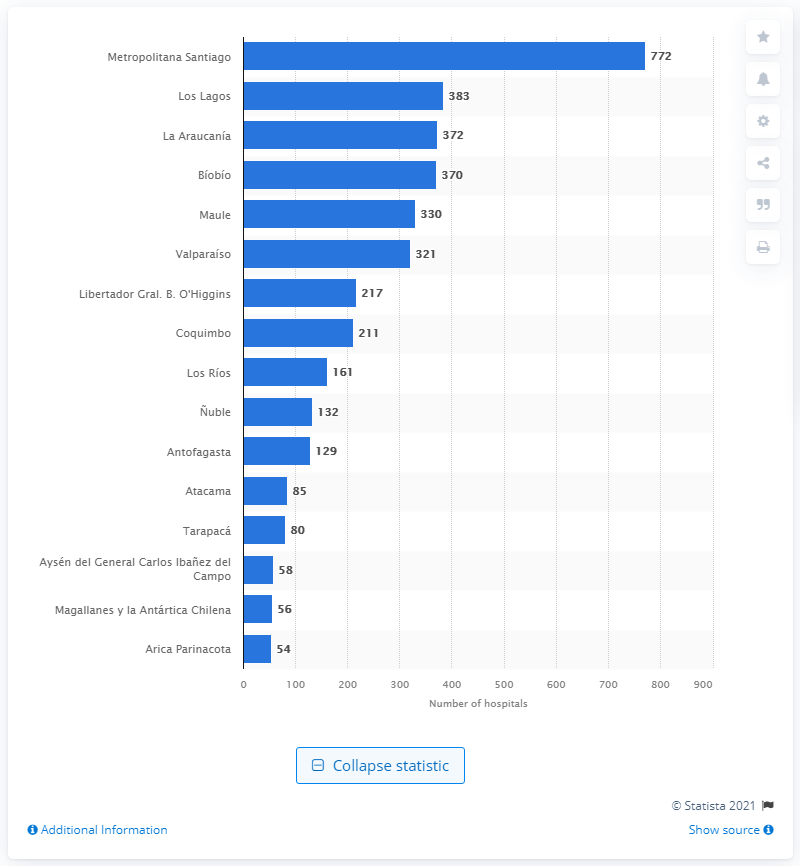List a handful of essential elements in this visual. Chile's Los Lagos region has the highest number of hospitals. 